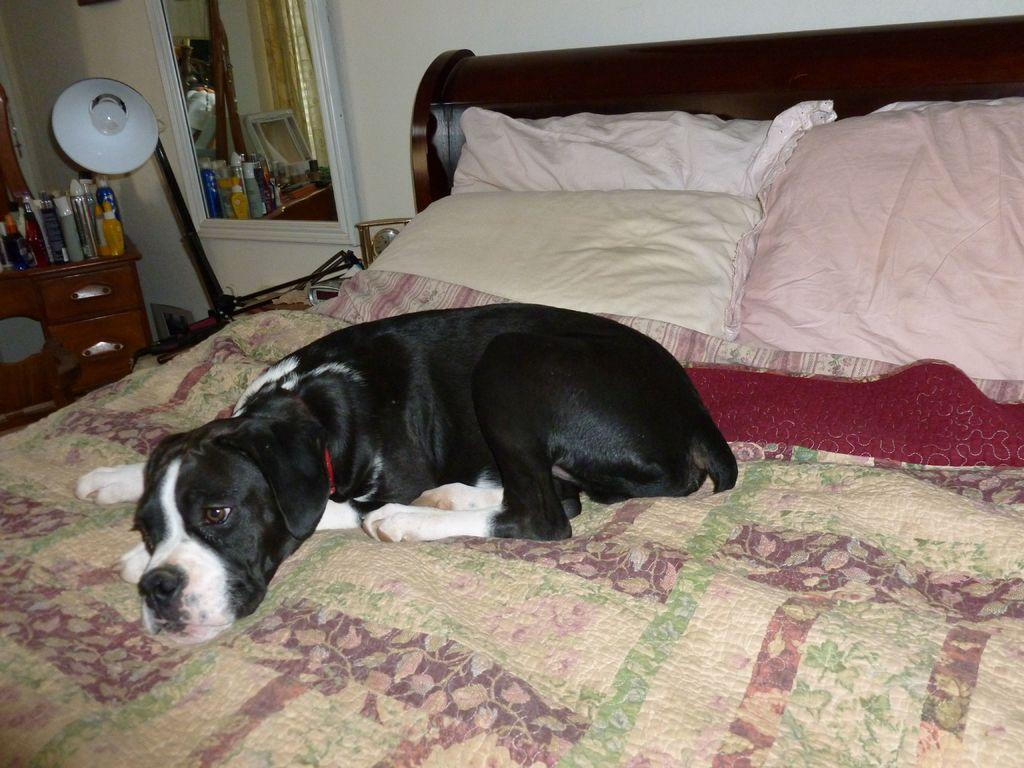What animal is on the bed in the image? There is a dog on the bed in the image. What can be seen in the background of the image? There is a wall, a mirror, a lamp, and a table in the background of the image. What objects are on the table in the background? There are bottles on the table in the background. What type of furniture is visible in the image? There is a bed and a table visible in the image. What type of decorative items are present in the image? There are pillows visible in the image. What grade does the dog receive for its performance on the street in the image? There is no mention of a dog's performance or a street in the image, so it is not possible to determine a grade. 